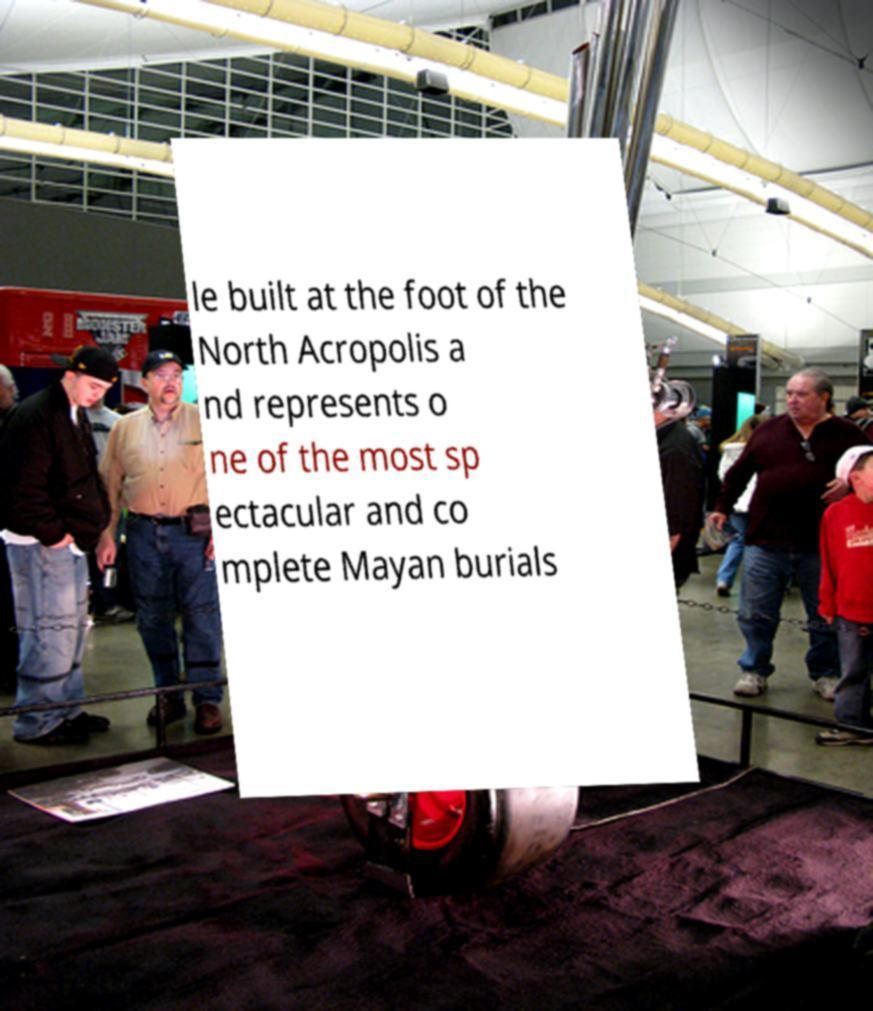Can you read and provide the text displayed in the image?This photo seems to have some interesting text. Can you extract and type it out for me? le built at the foot of the North Acropolis a nd represents o ne of the most sp ectacular and co mplete Mayan burials 